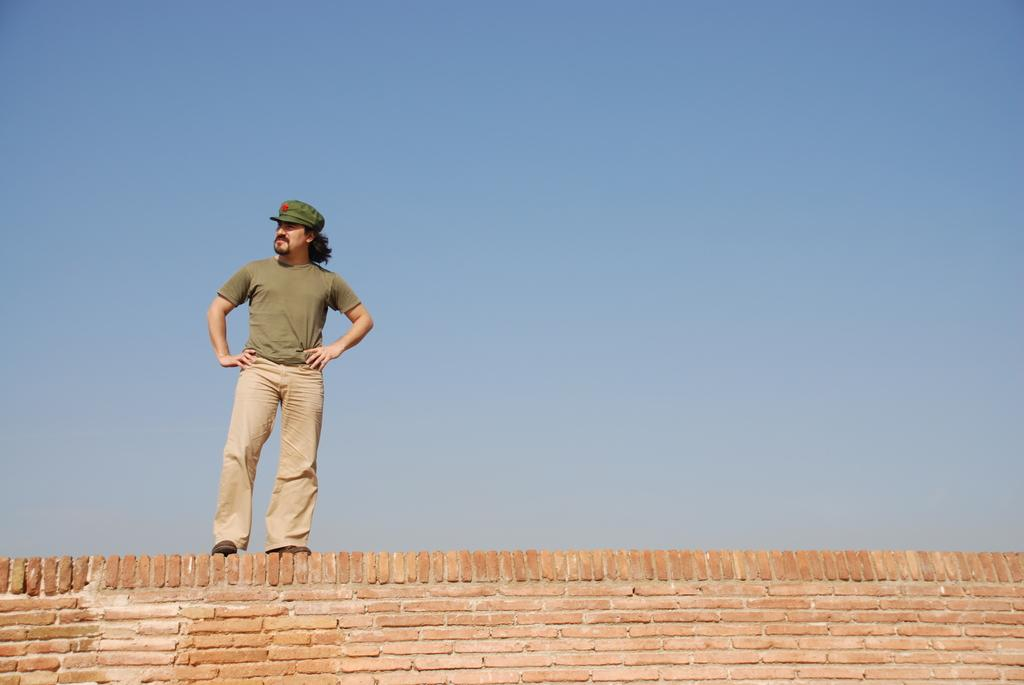Who is present in the image? There is a man in the image. What is the man doing in the image? The man is standing on a brick wall. What is the man wearing in the image? The man is wearing a green t-shirt and green pants. He is also wearing a cap. What can be seen in the background of the image? The sky in the background is blue. What type of linen is the man using to write on in the image? There is no linen or writing activity present in the image. What kind of vessel is the man carrying in the image? There is no vessel present in the image; the man is simply standing on a brick wall. 